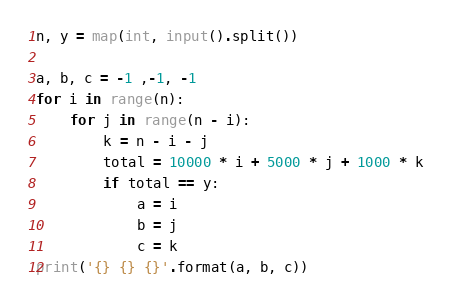Convert code to text. <code><loc_0><loc_0><loc_500><loc_500><_Python_>n, y = map(int, input().split())

a, b, c = -1 ,-1, -1
for i in range(n):
    for j in range(n - i):
        k = n - i - j
        total = 10000 * i + 5000 * j + 1000 * k
        if total == y:
            a = i
            b = j 
            c = k
print('{} {} {}'.format(a, b, c))
</code> 